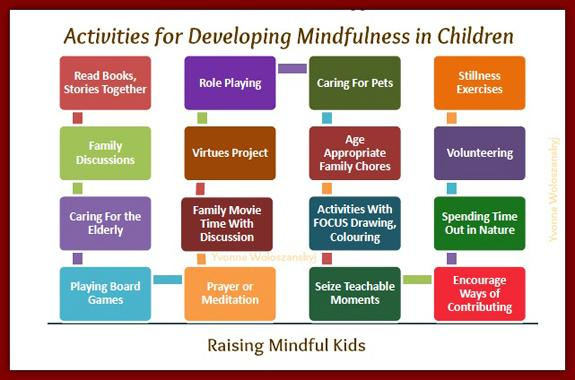Give some essential details in this illustration. The recommendation is to assign age-appropriate family chores to families. The infographic lists 16 activities for developing mindfulness in children. 